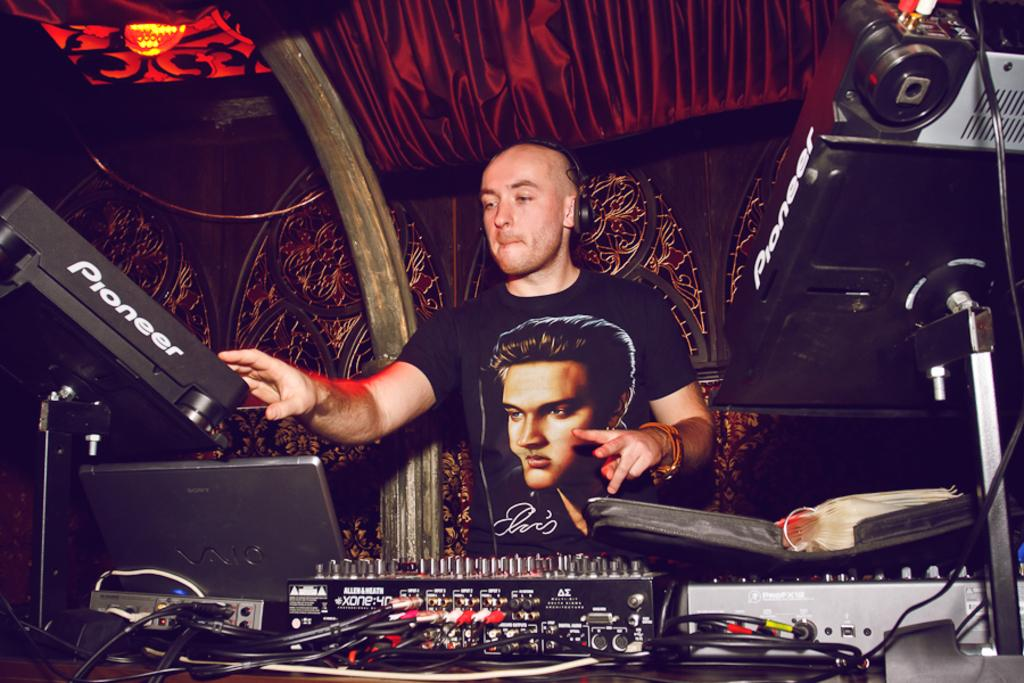What is the person in the image doing? The person is standing in the image. What can be seen on the person's head? The person is wearing a headset. What is in front of the person on the table? There is a laptop and a book in front of the person. What is visible in the background of the image? There is a wall and curtains in the background of the image. What type of flower is growing on the person's wing in the image? There is no flower or wing present in the image; the person is standing with a headset and there are objects in front of them on a table. 